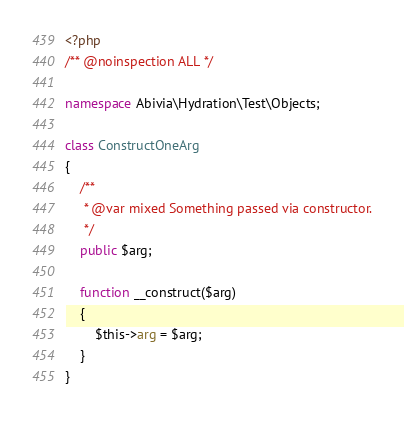<code> <loc_0><loc_0><loc_500><loc_500><_PHP_><?php
/** @noinspection ALL */

namespace Abivia\Hydration\Test\Objects;

class ConstructOneArg
{
    /**
     * @var mixed Something passed via constructor.
     */
    public $arg;

    function __construct($arg)
    {
        $this->arg = $arg;
    }
}</code> 